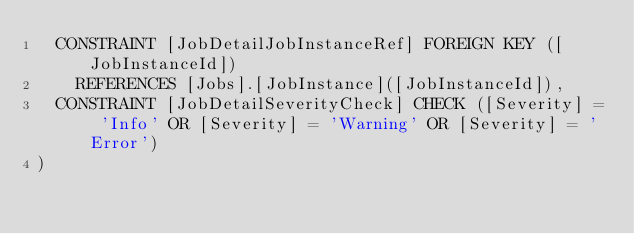Convert code to text. <code><loc_0><loc_0><loc_500><loc_500><_SQL_>	CONSTRAINT [JobDetailJobInstanceRef] FOREIGN KEY ([JobInstanceId])
		REFERENCES [Jobs].[JobInstance]([JobInstanceId]),
	CONSTRAINT [JobDetailSeverityCheck] CHECK ([Severity] = 'Info' OR [Severity] = 'Warning' OR [Severity] = 'Error')
)
</code> 